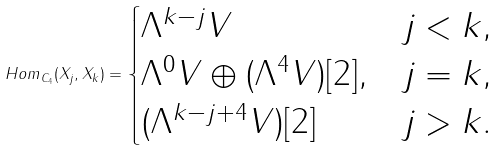<formula> <loc_0><loc_0><loc_500><loc_500>H o m _ { C _ { 4 } } ( X _ { j } , X _ { k } ) = \begin{cases} \Lambda ^ { k - j } V & j < k , \\ \Lambda ^ { 0 } V \oplus ( \Lambda ^ { 4 } V ) [ 2 ] , & j = k , \\ ( \Lambda ^ { k - j + 4 } V ) [ 2 ] & j > k . \end{cases}</formula> 